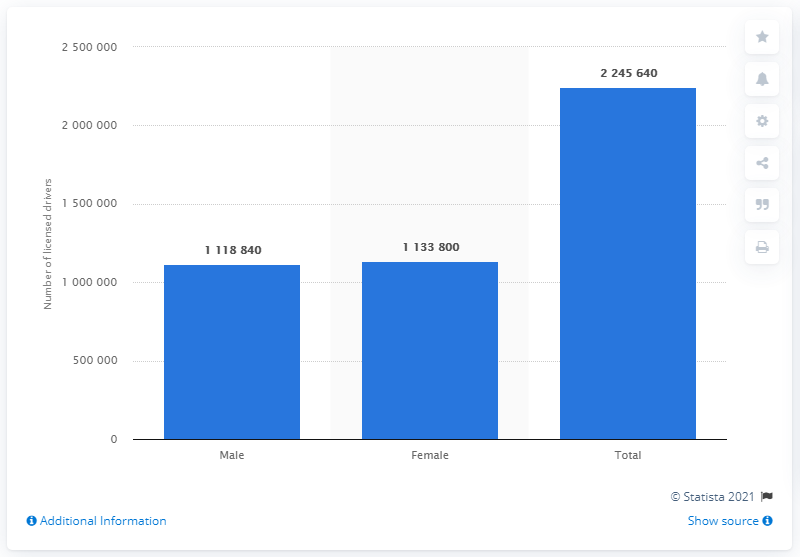Identify some key points in this picture. In 2016, there were 111,840 female drivers on the roads in the state of Iowa. 